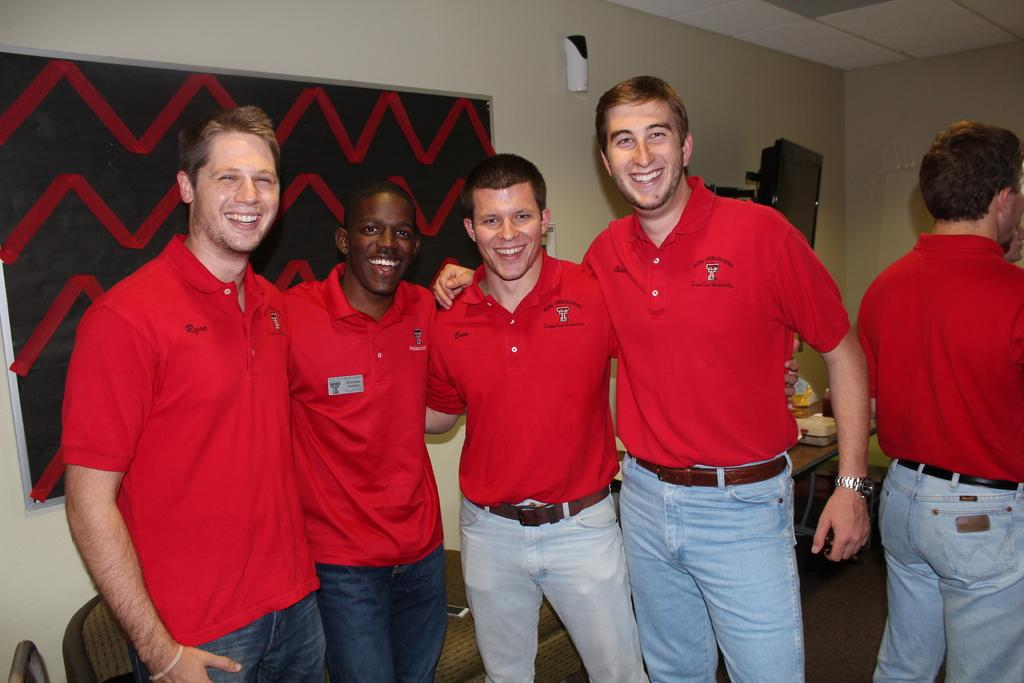What are the men in the image wearing? The men are wearing red t-shirts. What can be seen on the wall in the image? There is a board on the wall in the image. What else is present on the ground in the image? There are other items on the ground in the image. What causes the men to feel shame in the image? There is no indication in the image that the men are feeling shame, and therefore no cause can be determined. 